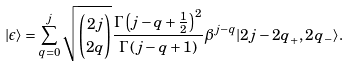Convert formula to latex. <formula><loc_0><loc_0><loc_500><loc_500>| \epsilon \rangle = \sum _ { q = 0 } ^ { j } { \sqrt { \binom { 2 j } { 2 q } } \frac { \Gamma \left ( j - q + \frac { 1 } { 2 } \right ) ^ { 2 } } { \Gamma \left ( j - q + 1 \right ) } } \beta ^ { j - q } | { 2 j - 2 q } _ { + } , 2 q _ { - } \rangle .</formula> 